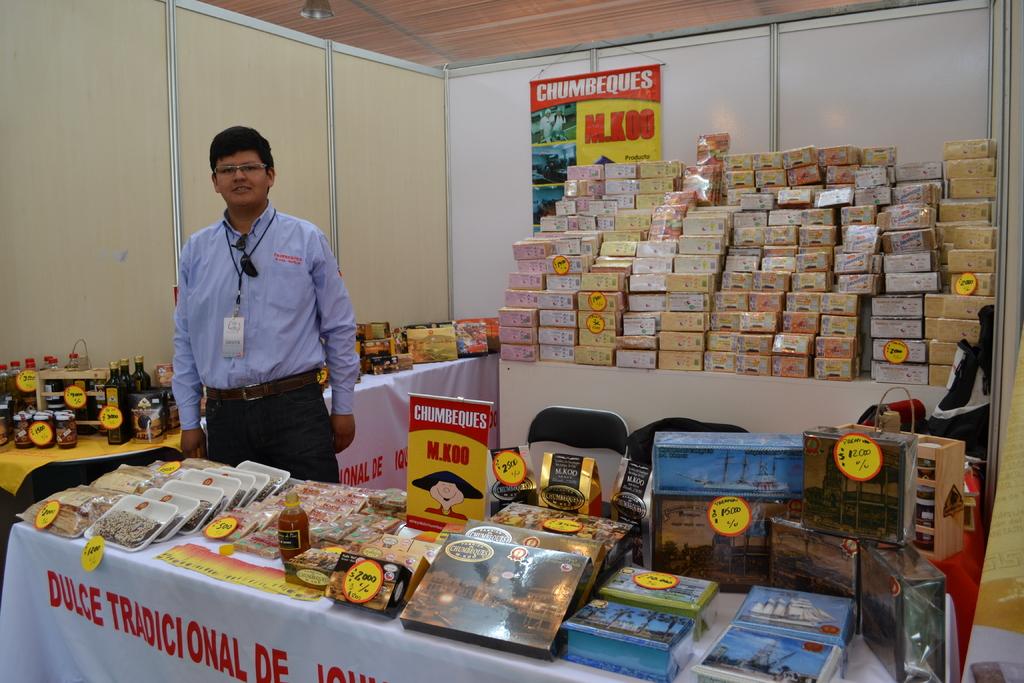What type of food are these?
Offer a very short reply. Chumbeques. Some food product?
Your answer should be very brief. Yes. 